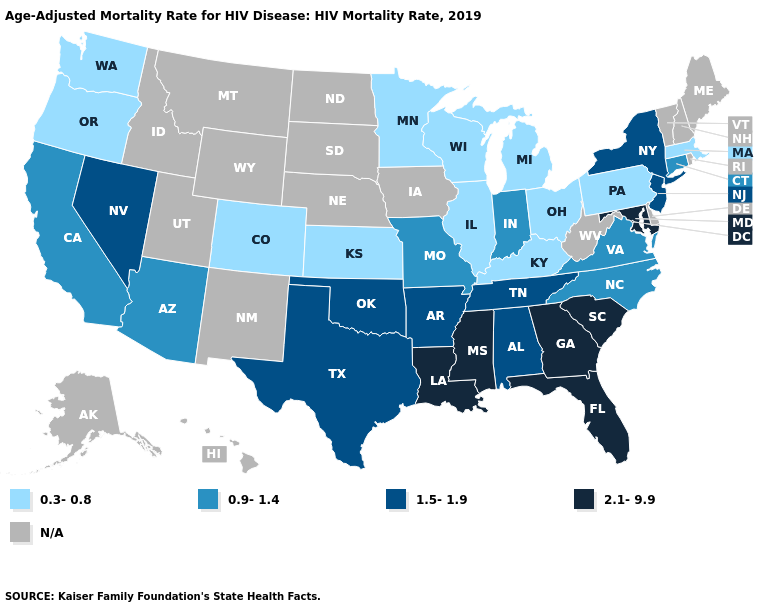Among the states that border Vermont , does New York have the lowest value?
Be succinct. No. Among the states that border Arizona , does California have the highest value?
Concise answer only. No. Name the states that have a value in the range 1.5-1.9?
Answer briefly. Alabama, Arkansas, Nevada, New Jersey, New York, Oklahoma, Tennessee, Texas. What is the lowest value in states that border South Dakota?
Keep it brief. 0.3-0.8. Among the states that border Georgia , which have the highest value?
Write a very short answer. Florida, South Carolina. What is the value of Vermont?
Short answer required. N/A. What is the lowest value in the West?
Short answer required. 0.3-0.8. Name the states that have a value in the range 2.1-9.9?
Write a very short answer. Florida, Georgia, Louisiana, Maryland, Mississippi, South Carolina. Name the states that have a value in the range 2.1-9.9?
Concise answer only. Florida, Georgia, Louisiana, Maryland, Mississippi, South Carolina. Name the states that have a value in the range 1.5-1.9?
Short answer required. Alabama, Arkansas, Nevada, New Jersey, New York, Oklahoma, Tennessee, Texas. What is the value of Oregon?
Quick response, please. 0.3-0.8. Name the states that have a value in the range 0.9-1.4?
Give a very brief answer. Arizona, California, Connecticut, Indiana, Missouri, North Carolina, Virginia. Is the legend a continuous bar?
Answer briefly. No. 